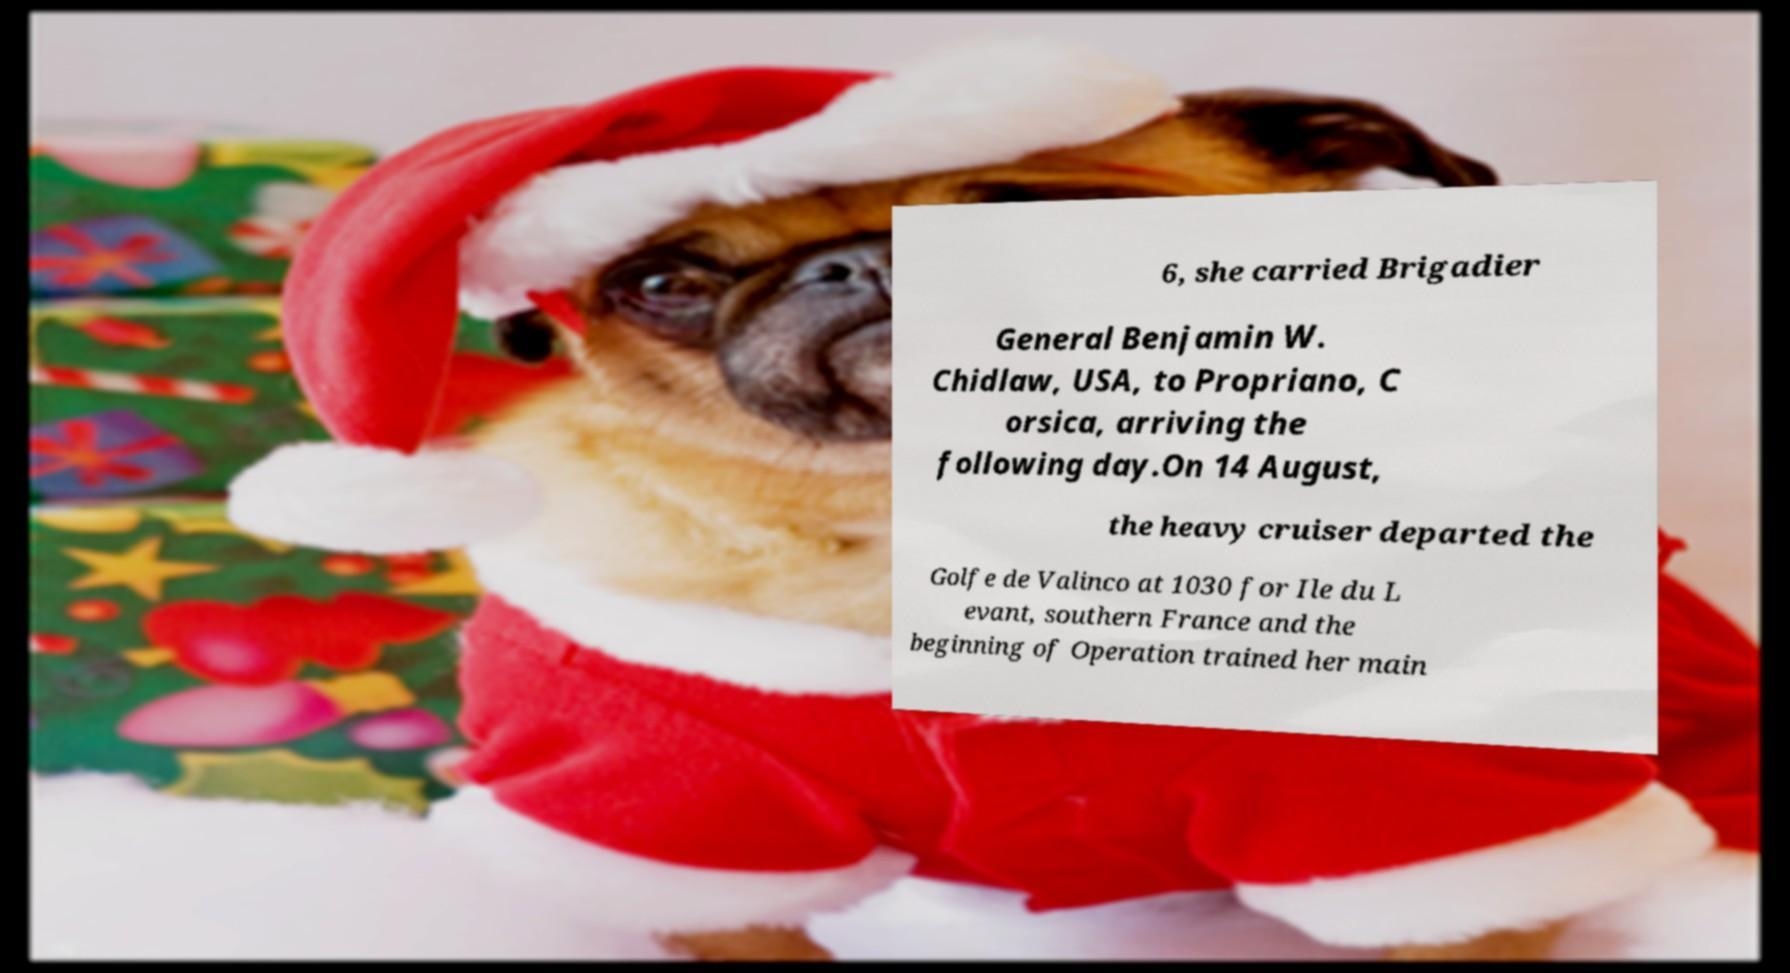There's text embedded in this image that I need extracted. Can you transcribe it verbatim? 6, she carried Brigadier General Benjamin W. Chidlaw, USA, to Propriano, C orsica, arriving the following day.On 14 August, the heavy cruiser departed the Golfe de Valinco at 1030 for Ile du L evant, southern France and the beginning of Operation trained her main 